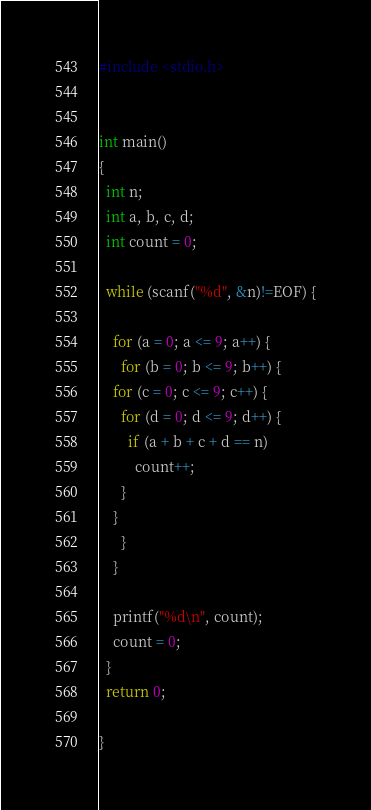<code> <loc_0><loc_0><loc_500><loc_500><_C_>#include <stdio.h>


int main()
{
  int n;
  int a, b, c, d;
  int count = 0;

  while (scanf("%d", &n)!=EOF) {

    for (a = 0; a <= 9; a++) {
      for (b = 0; b <= 9; b++) {
	for (c = 0; c <= 9; c++) {
	  for (d = 0; d <= 9; d++) {
	    if (a + b + c + d == n)
	      count++;
	  }
	}
      }
    }

    printf("%d\n", count);
    count = 0;
  }
  return 0;
  
}</code> 